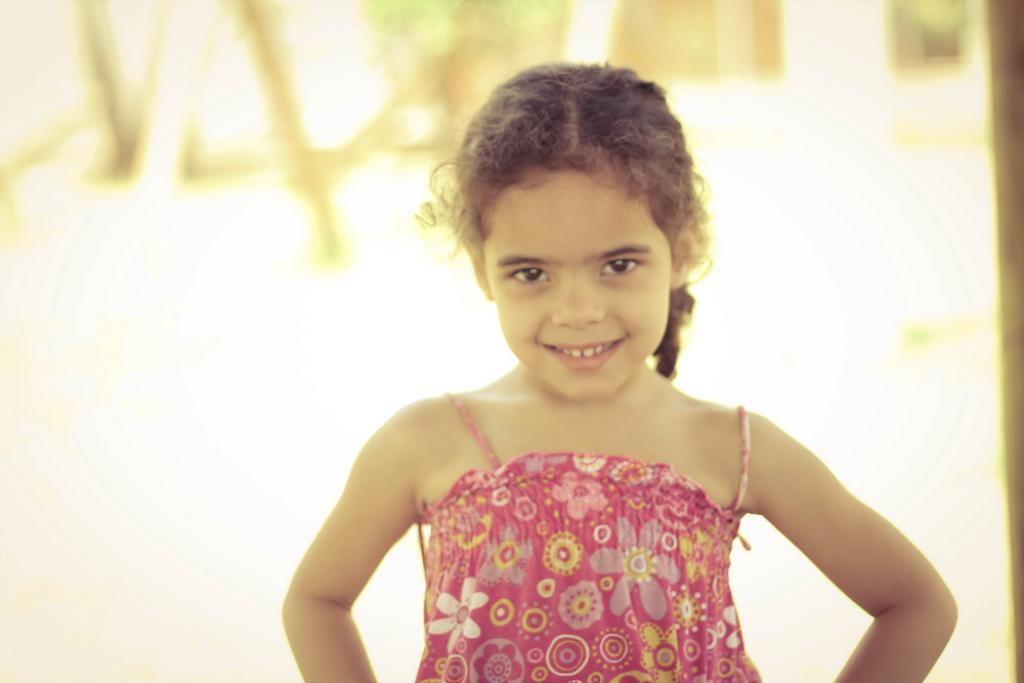In one or two sentences, can you explain what this image depicts? A girl is standing wearing pink dress. The background is blurred. 